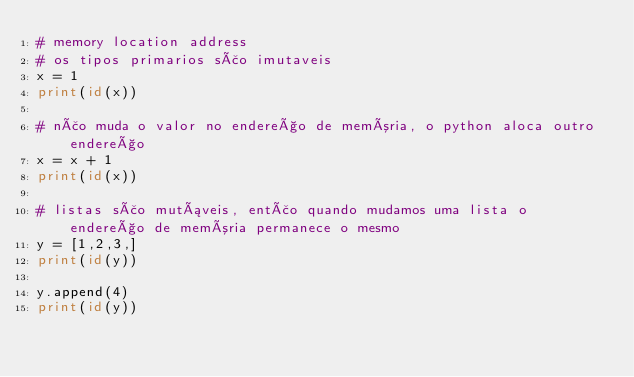Convert code to text. <code><loc_0><loc_0><loc_500><loc_500><_Python_># memory location address
# os tipos primarios são imutaveis
x = 1
print(id(x))

# não muda o valor no endereço de memória, o python aloca outro endereço
x = x + 1
print(id(x))

# listas são mutáveis, então quando mudamos uma lista o endereço de memória permanece o mesmo
y = [1,2,3,]
print(id(y))

y.append(4)
print(id(y))</code> 